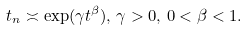Convert formula to latex. <formula><loc_0><loc_0><loc_500><loc_500>t _ { n } \asymp \exp ( \gamma t ^ { \beta } ) , \, \gamma > 0 , \, 0 < \beta < 1 .</formula> 